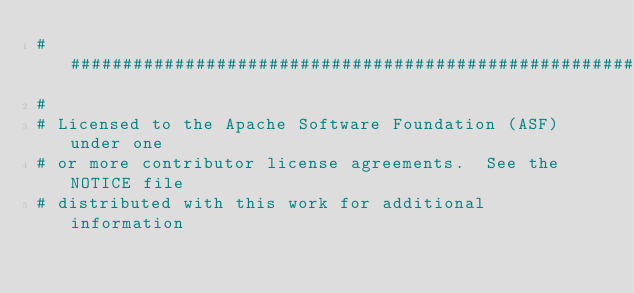<code> <loc_0><loc_0><loc_500><loc_500><_Python_>###############################################################################
#
# Licensed to the Apache Software Foundation (ASF) under one
# or more contributor license agreements.  See the NOTICE file
# distributed with this work for additional information</code> 